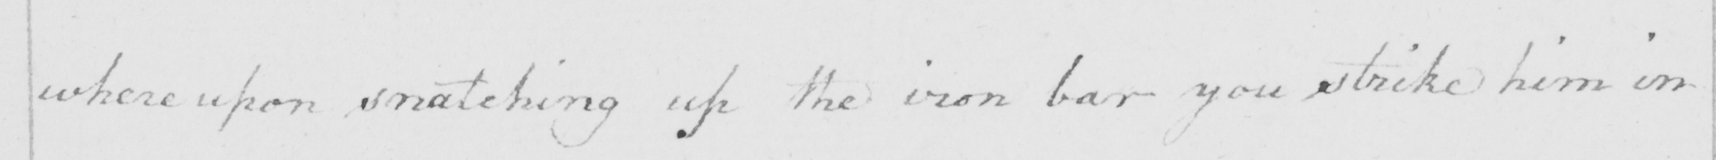Can you read and transcribe this handwriting? where upon snatching up the iron bar you strike him in 